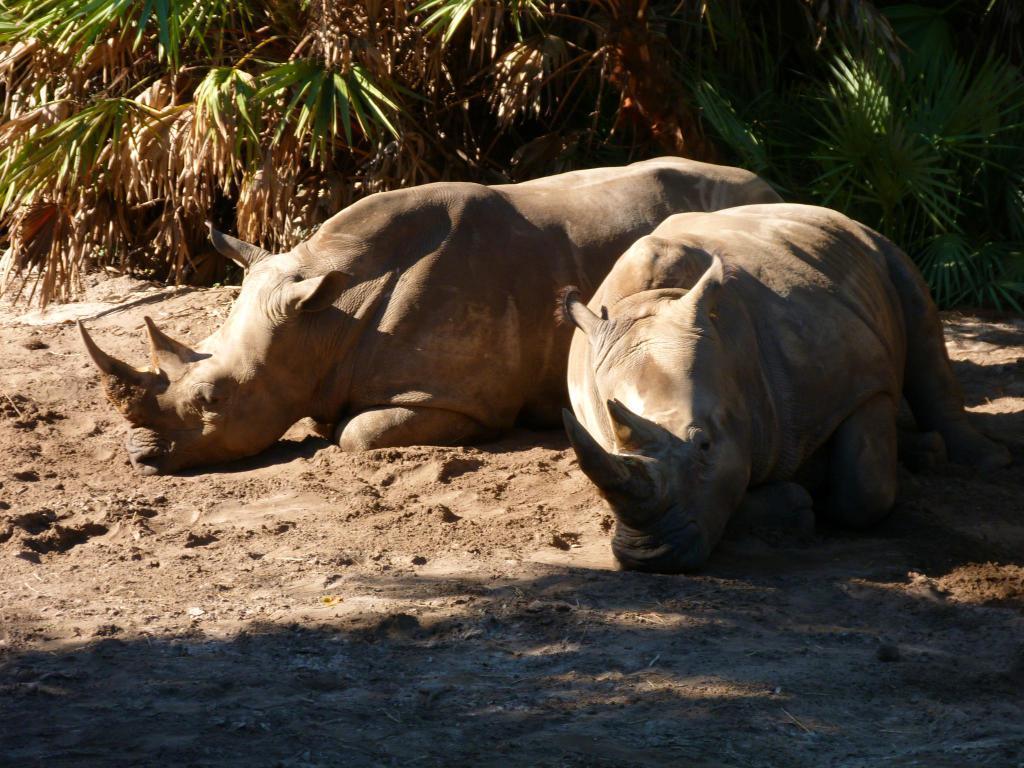How would you summarize this image in a sentence or two? Front we can see two rhinoceros. Background there are plants. 